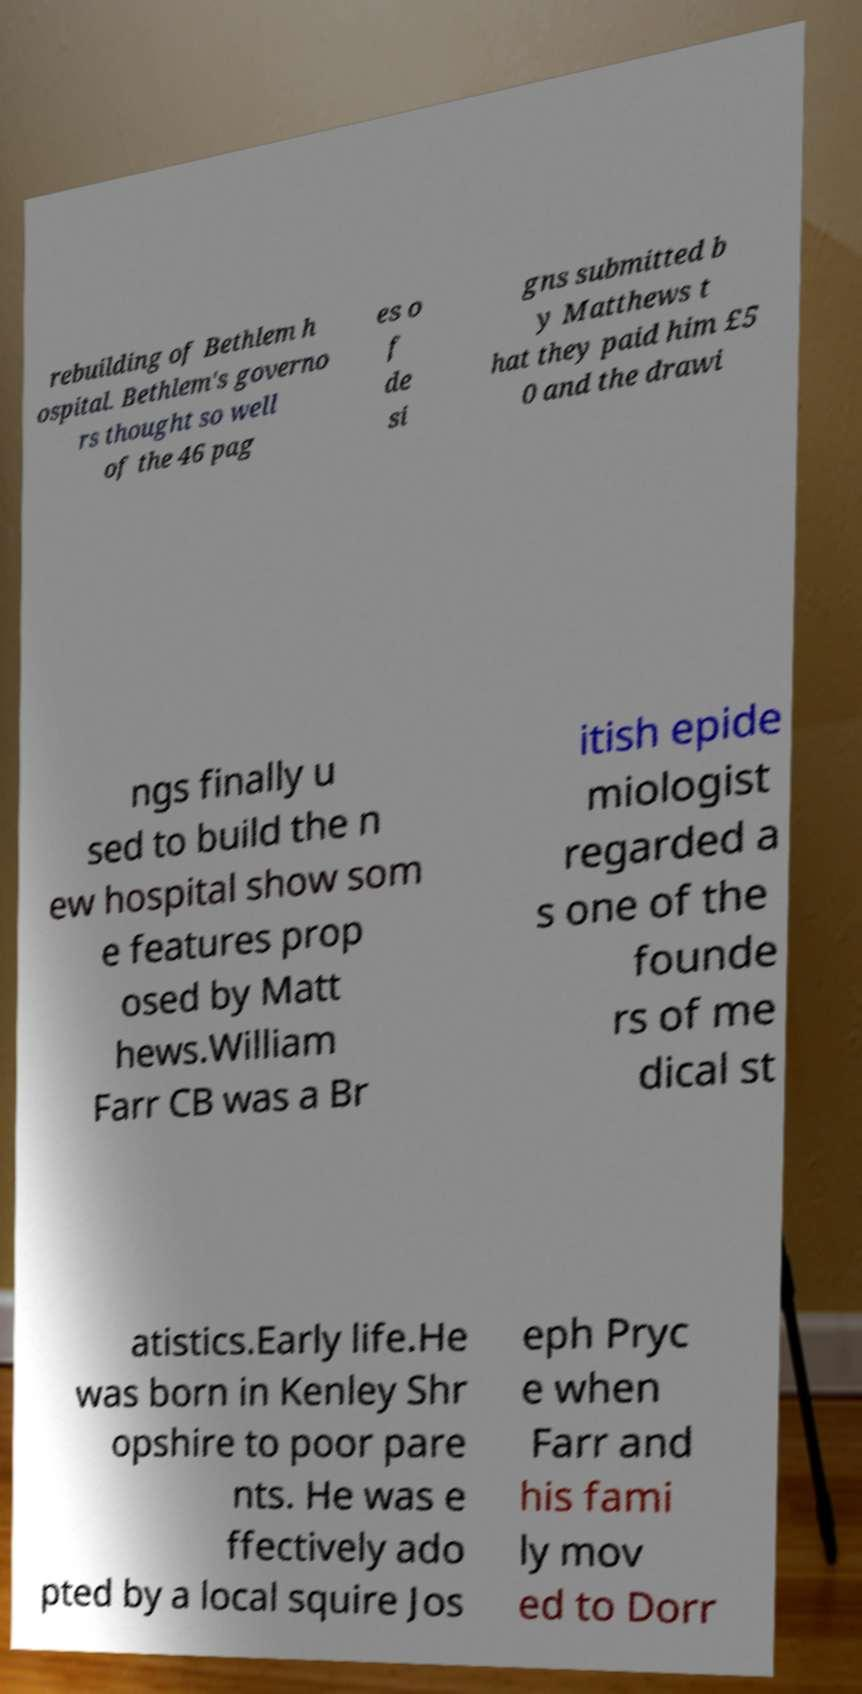I need the written content from this picture converted into text. Can you do that? rebuilding of Bethlem h ospital. Bethlem's governo rs thought so well of the 46 pag es o f de si gns submitted b y Matthews t hat they paid him £5 0 and the drawi ngs finally u sed to build the n ew hospital show som e features prop osed by Matt hews.William Farr CB was a Br itish epide miologist regarded a s one of the founde rs of me dical st atistics.Early life.He was born in Kenley Shr opshire to poor pare nts. He was e ffectively ado pted by a local squire Jos eph Pryc e when Farr and his fami ly mov ed to Dorr 